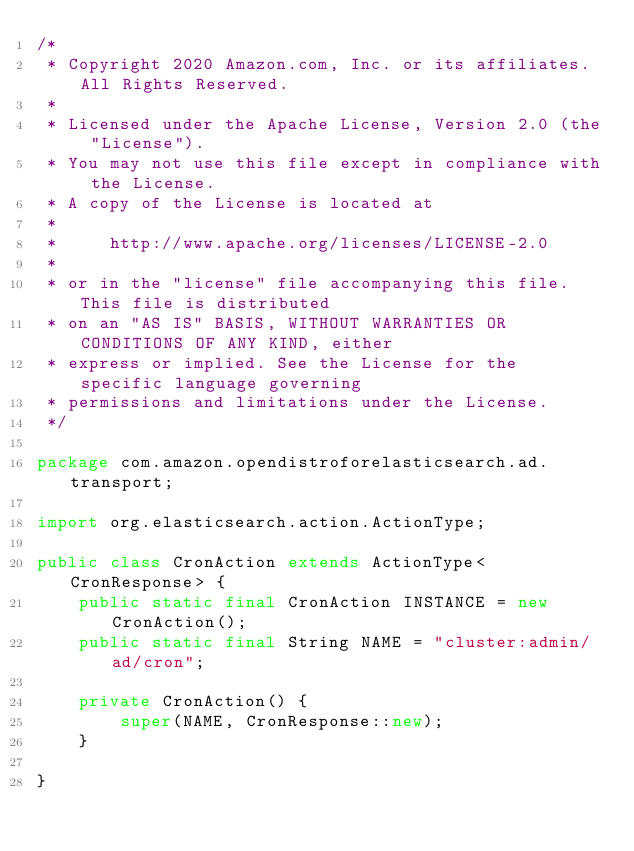Convert code to text. <code><loc_0><loc_0><loc_500><loc_500><_Java_>/*
 * Copyright 2020 Amazon.com, Inc. or its affiliates. All Rights Reserved.
 *
 * Licensed under the Apache License, Version 2.0 (the "License").
 * You may not use this file except in compliance with the License.
 * A copy of the License is located at
 *
 *     http://www.apache.org/licenses/LICENSE-2.0
 *
 * or in the "license" file accompanying this file. This file is distributed
 * on an "AS IS" BASIS, WITHOUT WARRANTIES OR CONDITIONS OF ANY KIND, either
 * express or implied. See the License for the specific language governing
 * permissions and limitations under the License.
 */

package com.amazon.opendistroforelasticsearch.ad.transport;

import org.elasticsearch.action.ActionType;

public class CronAction extends ActionType<CronResponse> {
    public static final CronAction INSTANCE = new CronAction();
    public static final String NAME = "cluster:admin/ad/cron";

    private CronAction() {
        super(NAME, CronResponse::new);
    }

}
</code> 